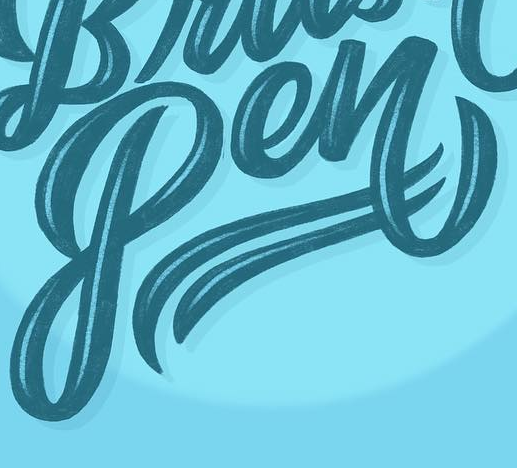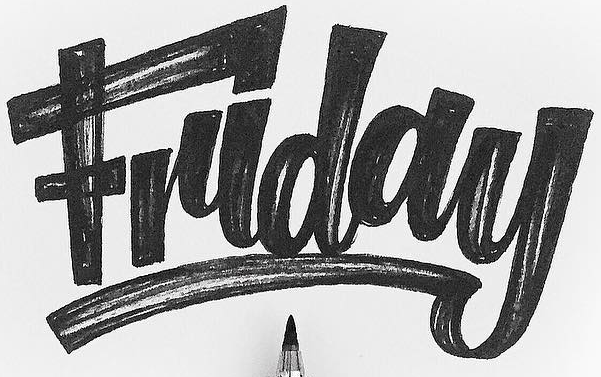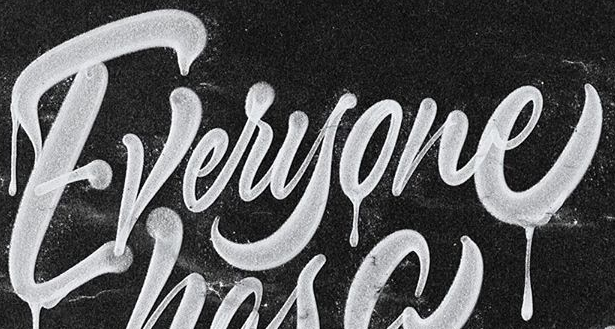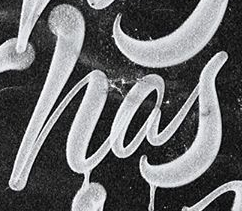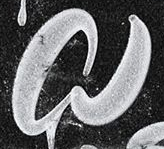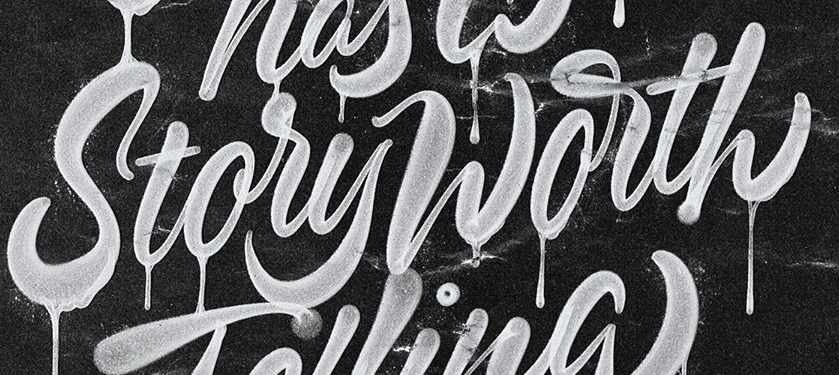Transcribe the words shown in these images in order, separated by a semicolon. Pen; Friday; Everyone; has; a; StoryWorth 